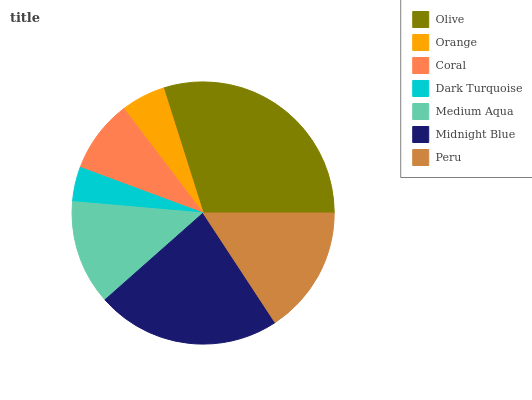Is Dark Turquoise the minimum?
Answer yes or no. Yes. Is Olive the maximum?
Answer yes or no. Yes. Is Orange the minimum?
Answer yes or no. No. Is Orange the maximum?
Answer yes or no. No. Is Olive greater than Orange?
Answer yes or no. Yes. Is Orange less than Olive?
Answer yes or no. Yes. Is Orange greater than Olive?
Answer yes or no. No. Is Olive less than Orange?
Answer yes or no. No. Is Medium Aqua the high median?
Answer yes or no. Yes. Is Medium Aqua the low median?
Answer yes or no. Yes. Is Peru the high median?
Answer yes or no. No. Is Dark Turquoise the low median?
Answer yes or no. No. 